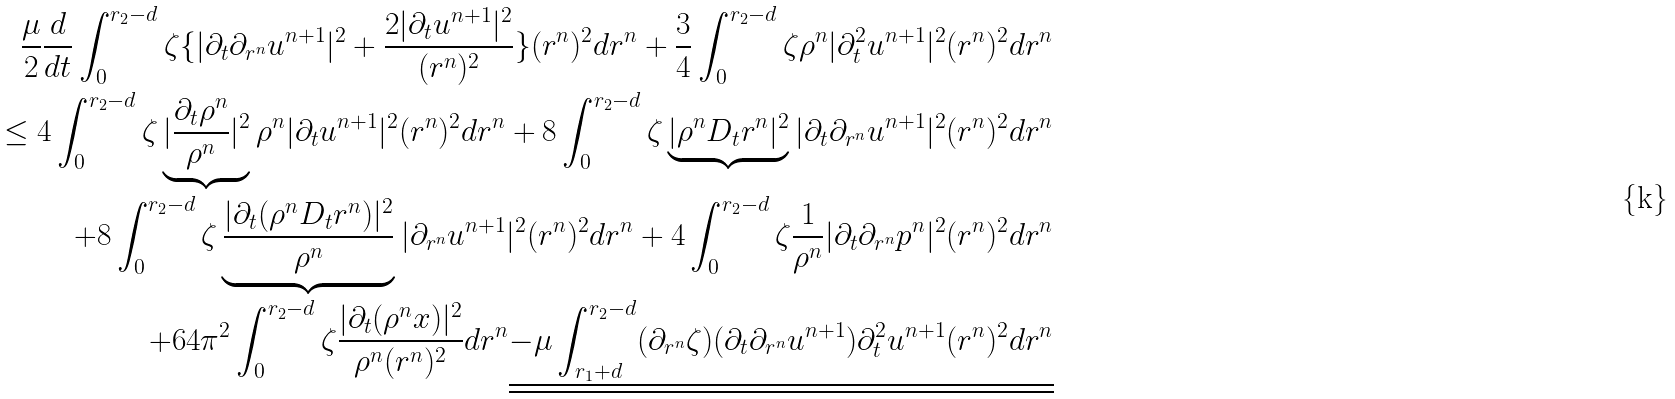<formula> <loc_0><loc_0><loc_500><loc_500>\frac { \mu } { 2 } \frac { d } { d t } \int _ { 0 } ^ { r _ { 2 } - d } \zeta \{ | \partial _ { t } \partial _ { r ^ { n } } u ^ { n + 1 } | ^ { 2 } + \frac { 2 | \partial _ { t } u ^ { n + 1 } | ^ { 2 } } { ( r ^ { n } ) ^ { 2 } } \} ( r ^ { n } ) ^ { 2 } d r ^ { n } + \frac { 3 } { 4 } \int _ { 0 } ^ { r _ { 2 } - d } \zeta \rho ^ { n } | \partial _ { t } ^ { 2 } u ^ { n + 1 } | ^ { 2 } ( r ^ { n } ) ^ { 2 } d r ^ { n } \\ \leq 4 \int _ { 0 } ^ { r _ { 2 } - d } \zeta \underbrace { | \frac { \partial _ { t } \rho ^ { n } } { \rho ^ { n } } | ^ { 2 } } \rho ^ { n } | \partial _ { t } u ^ { n + 1 } | ^ { 2 } ( r ^ { n } ) ^ { 2 } d r ^ { n } + 8 \int _ { 0 } ^ { r _ { 2 } - d } \zeta \underbrace { | \rho ^ { n } D _ { t } r ^ { n } | ^ { 2 } } | \partial _ { t } \partial _ { r ^ { n } } u ^ { n + 1 } | ^ { 2 } ( r ^ { n } ) ^ { 2 } d r ^ { n } \\ + 8 \int _ { 0 } ^ { r _ { 2 } - d } \zeta \underbrace { \frac { | \partial _ { t } ( \rho ^ { n } D _ { t } r ^ { n } ) | ^ { 2 } } { \rho ^ { n } } } | \partial _ { r ^ { n } } u ^ { n + 1 } | ^ { 2 } ( r ^ { n } ) ^ { 2 } d r ^ { n } + 4 \int _ { 0 } ^ { r _ { 2 } - d } \zeta \frac { 1 } { \rho ^ { n } } | \partial _ { t } \partial _ { r ^ { n } } p ^ { n } | ^ { 2 } ( r ^ { n } ) ^ { 2 } d r ^ { n } \\ + 6 4 \pi ^ { 2 } \int _ { 0 } ^ { r _ { 2 } - d } \zeta \frac { | \partial _ { t } ( \rho ^ { n } x ) | ^ { 2 } } { \rho ^ { n } ( r ^ { n } ) ^ { 2 } } d r ^ { n } \underline { \underline { - \mu \int _ { r _ { 1 } + d } ^ { r _ { 2 } - d } ( \partial _ { r ^ { n } } \zeta ) ( \partial _ { t } \partial _ { r ^ { n } } u ^ { n + 1 } ) \partial _ { t } ^ { 2 } u ^ { n + 1 } ( r ^ { n } ) ^ { 2 } d r ^ { n } } }</formula> 